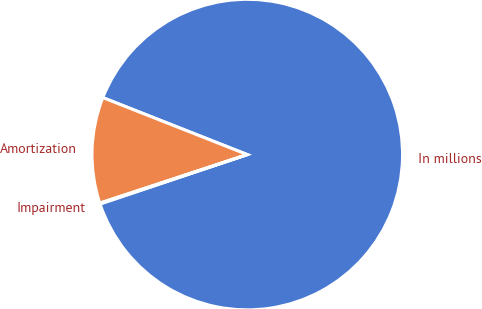Convert chart. <chart><loc_0><loc_0><loc_500><loc_500><pie_chart><fcel>In millions<fcel>Amortization<fcel>Impairment<nl><fcel>88.87%<fcel>11.04%<fcel>0.09%<nl></chart> 